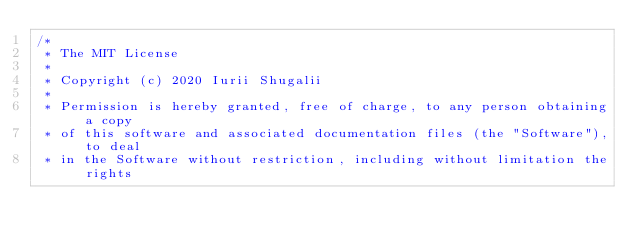Convert code to text. <code><loc_0><loc_0><loc_500><loc_500><_Java_>/*
 * The MIT License
 *
 * Copyright (c) 2020 Iurii Shugalii
 *
 * Permission is hereby granted, free of charge, to any person obtaining a copy
 * of this software and associated documentation files (the "Software"), to deal
 * in the Software without restriction, including without limitation the rights</code> 